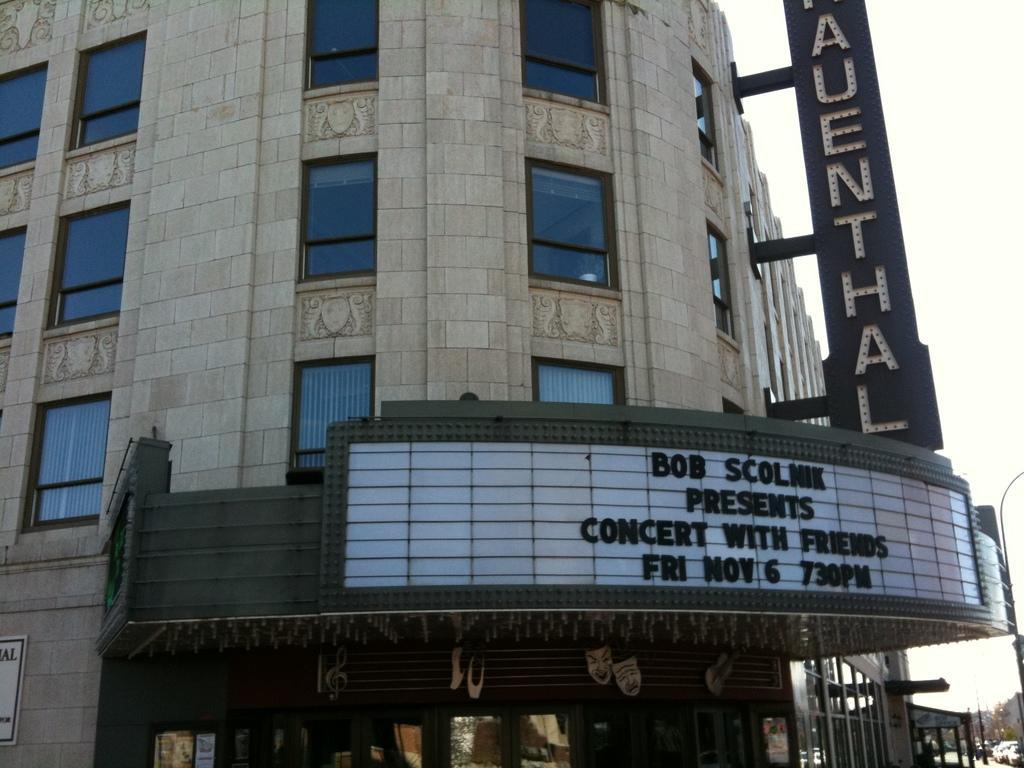Could you give a brief overview of what you see in this image? In this image we can see a building with windows and the sign boards with some text on them. On the right side we can see vehicles on the ground, trees, some poles and the sky. 